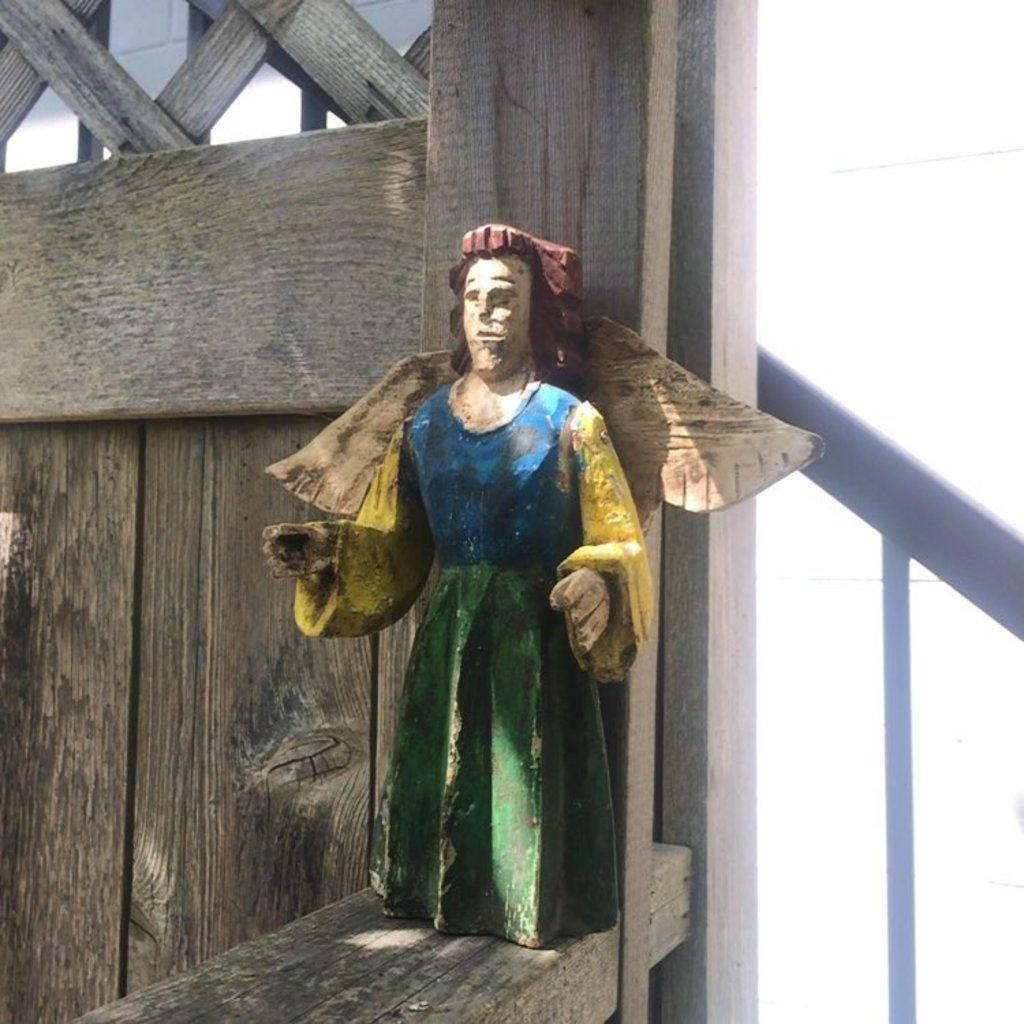What is the main object in the middle of the image? There is a toy in the middle of the image. What type of wall can be seen in the background of the image? There is a wood wall in the background of the image. What material is the object on the right side of the image made of? There is a metal rod on the right side of the image. What color is visible on the right side of the image? There is a white color visible on the right side of the image. Where are the chickens located in the image? There are no chickens present in the image. What type of sand can be seen on the street in the image? There is no street or sand present in the image. 